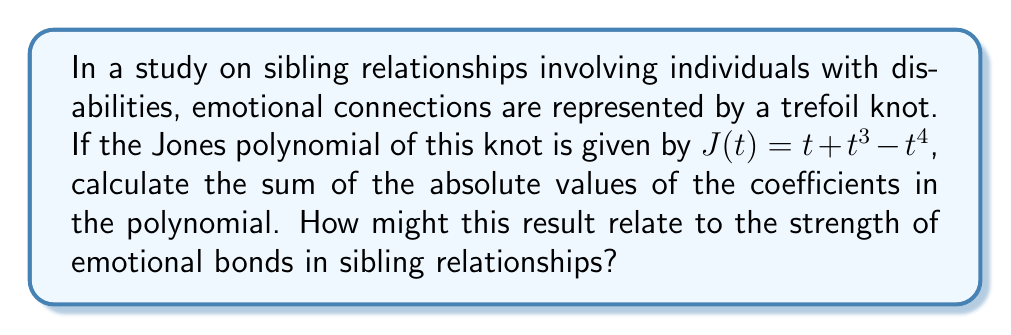Could you help me with this problem? To solve this problem, we'll follow these steps:

1. Identify the coefficients in the Jones polynomial:
   $J(t) = t + t^3 - t^4$
   Coefficients are: 1, 1, and -1

2. Take the absolute value of each coefficient:
   $|1| = 1$
   $|1| = 1$
   $|-1| = 1$

3. Sum the absolute values:
   $1 + 1 + 1 = 3$

In the context of sibling relationships and emotional connections:
The sum of the absolute values of the coefficients in a Jones polynomial can be interpreted as a measure of the complexity or "richness" of the knot. In this case, a sum of 3 suggests a moderately complex emotional connection.

For a psychology student studying sibling relationships involving individuals with disabilities, this result could be interpreted as representing the multifaceted nature of these relationships. The presence of both positive and negative coefficients (1 and -1) might indicate a mix of supportive and challenging aspects in the relationship, which is common in sibling dynamics, especially when one sibling has a disability.

The relatively low sum (3) could suggest that while these relationships have some complexity, they may not be overwhelmingly complicated, potentially indicating resilience or adaptability in the sibling bond.
Answer: 3 